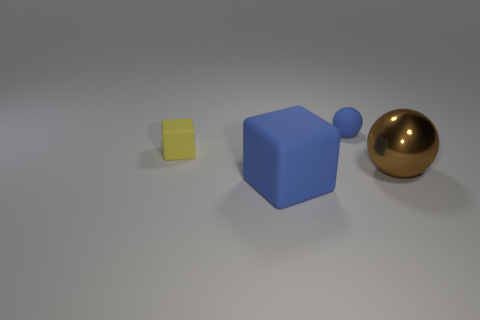Add 2 big blue objects. How many objects exist? 6 Subtract all blue balls. How many balls are left? 1 Subtract 1 cubes. How many cubes are left? 1 Add 2 big rubber objects. How many big rubber objects exist? 3 Subtract 0 red blocks. How many objects are left? 4 Subtract all yellow cubes. Subtract all green cylinders. How many cubes are left? 1 Subtract all gray blocks. How many yellow spheres are left? 0 Subtract all big blue objects. Subtract all spheres. How many objects are left? 1 Add 4 small rubber cubes. How many small rubber cubes are left? 5 